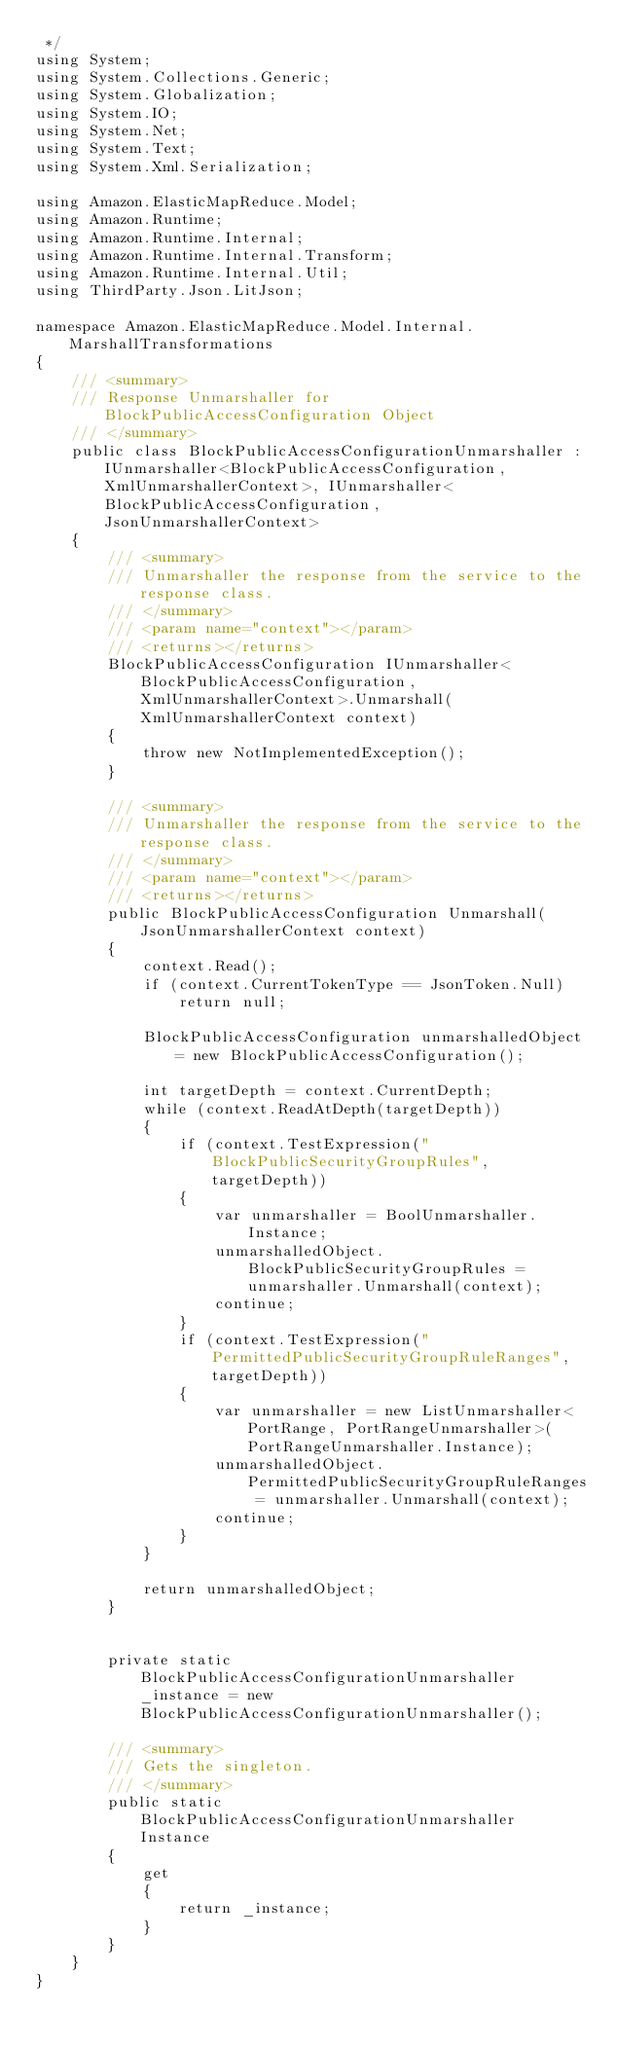Convert code to text. <code><loc_0><loc_0><loc_500><loc_500><_C#_> */
using System;
using System.Collections.Generic;
using System.Globalization;
using System.IO;
using System.Net;
using System.Text;
using System.Xml.Serialization;

using Amazon.ElasticMapReduce.Model;
using Amazon.Runtime;
using Amazon.Runtime.Internal;
using Amazon.Runtime.Internal.Transform;
using Amazon.Runtime.Internal.Util;
using ThirdParty.Json.LitJson;

namespace Amazon.ElasticMapReduce.Model.Internal.MarshallTransformations
{
    /// <summary>
    /// Response Unmarshaller for BlockPublicAccessConfiguration Object
    /// </summary>  
    public class BlockPublicAccessConfigurationUnmarshaller : IUnmarshaller<BlockPublicAccessConfiguration, XmlUnmarshallerContext>, IUnmarshaller<BlockPublicAccessConfiguration, JsonUnmarshallerContext>
    {
        /// <summary>
        /// Unmarshaller the response from the service to the response class.
        /// </summary>  
        /// <param name="context"></param>
        /// <returns></returns>
        BlockPublicAccessConfiguration IUnmarshaller<BlockPublicAccessConfiguration, XmlUnmarshallerContext>.Unmarshall(XmlUnmarshallerContext context)
        {
            throw new NotImplementedException();
        }

        /// <summary>
        /// Unmarshaller the response from the service to the response class.
        /// </summary>  
        /// <param name="context"></param>
        /// <returns></returns>
        public BlockPublicAccessConfiguration Unmarshall(JsonUnmarshallerContext context)
        {
            context.Read();
            if (context.CurrentTokenType == JsonToken.Null) 
                return null;

            BlockPublicAccessConfiguration unmarshalledObject = new BlockPublicAccessConfiguration();
        
            int targetDepth = context.CurrentDepth;
            while (context.ReadAtDepth(targetDepth))
            {
                if (context.TestExpression("BlockPublicSecurityGroupRules", targetDepth))
                {
                    var unmarshaller = BoolUnmarshaller.Instance;
                    unmarshalledObject.BlockPublicSecurityGroupRules = unmarshaller.Unmarshall(context);
                    continue;
                }
                if (context.TestExpression("PermittedPublicSecurityGroupRuleRanges", targetDepth))
                {
                    var unmarshaller = new ListUnmarshaller<PortRange, PortRangeUnmarshaller>(PortRangeUnmarshaller.Instance);
                    unmarshalledObject.PermittedPublicSecurityGroupRuleRanges = unmarshaller.Unmarshall(context);
                    continue;
                }
            }
          
            return unmarshalledObject;
        }


        private static BlockPublicAccessConfigurationUnmarshaller _instance = new BlockPublicAccessConfigurationUnmarshaller();        

        /// <summary>
        /// Gets the singleton.
        /// </summary>  
        public static BlockPublicAccessConfigurationUnmarshaller Instance
        {
            get
            {
                return _instance;
            }
        }
    }
}</code> 